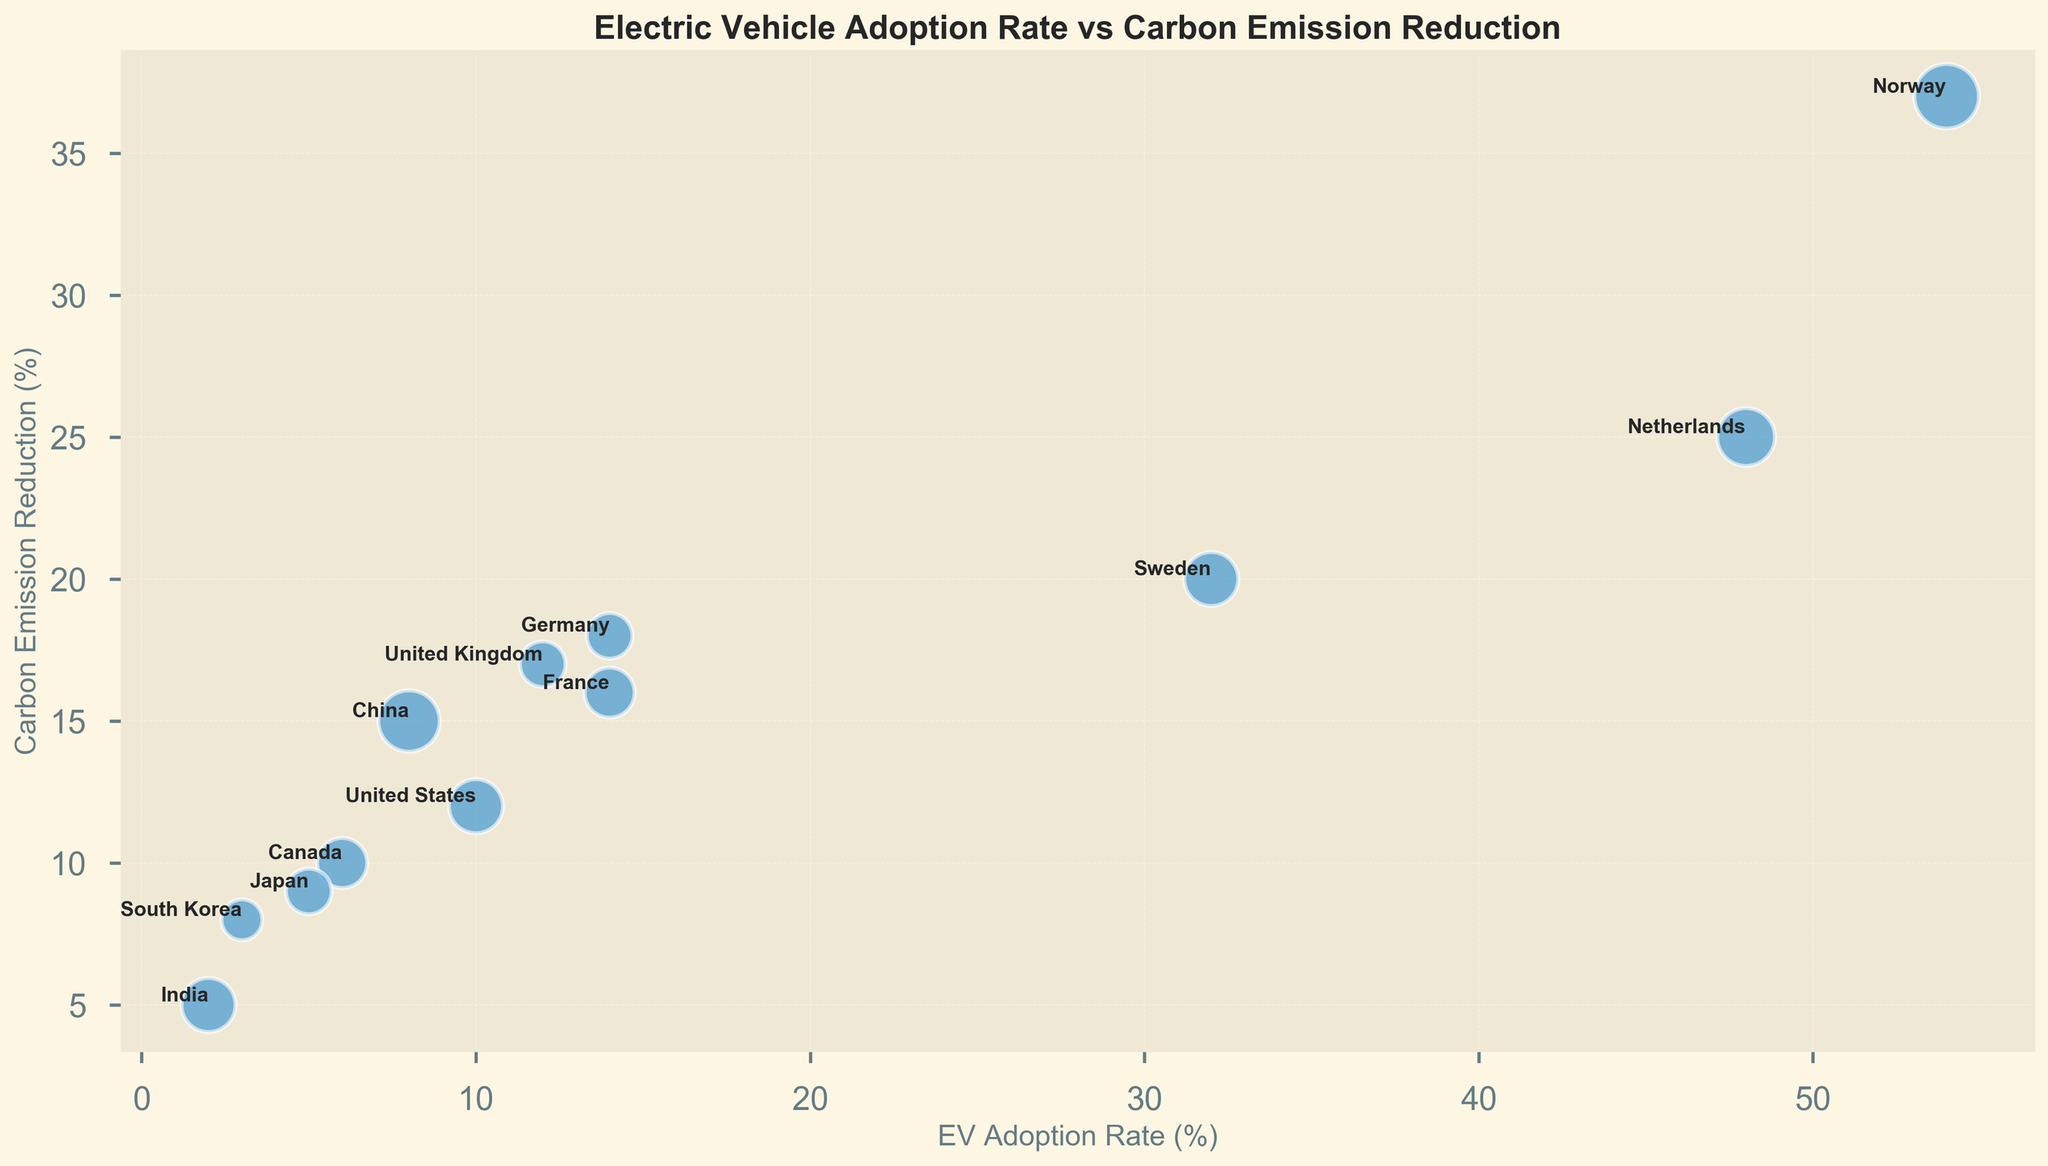Which country has the highest EV adoption rate? The figure shows different countries represented by bubbles in a scatter plot. The x-axis indicates the EV adoption rate. The bubble furthest to the right represents Norway with an EV adoption rate of 54%.
Answer: Norway Which country has the lowest carbon emission reduction? The y-axis of the plot represents carbon emission reduction. The bubble lowest on the y-axis is for India, with a carbon emission reduction of 5%.
Answer: India Comparing Norway and China, how much higher is Norway's carbon emission reduction compared to China’s? From the figure, the carbon emission reduction for Norway is 37%, and for China, it is 15%. The difference is 37% - 15% = 22%.
Answer: 22% Which country among Germany, France, and United States has the highest EV adoption rate, and what is it? Checking the x-axis positions of bubbles labeled Germany, France, and United States, Germany has an adoption rate of 14%, France is at 14%, and the United States is at 10%.
Answer: Germany and France (both 14%) What is the overall trend between EV adoption rate and carbon emission reduction? The chart shows a positive correlation: as the EV adoption rate increases (x-axis), the carbon emission reduction tends to increase (y-axis) as well.
Answer: Positive correlation If you average the EV adoption rates of the United Kingdom, France, and Canada, what do you get? The EV adoption rates are 12% (United Kingdom), 14% (France), and 6% (Canada). The average is calculated as (12% + 14% + 6%) / 3 = 32% / 3 ≈ 10.67%.
Answer: 10.67% Which country has the smallest bubble and what does that size represent? The smallest bubble represents South Korea. The size attribute corresponds to 0.4, which is scaled to 400 for visibility.
Answer: South Korea Visually, which country among India, Canada, and Japan has the largest bubble? By comparing the size of the bubbles representing India, Canada, and Japan, the largest bubble corresponds to India (0.7 scaled) compared to Canada's (0.6 scaled) and Japan's (0.5 scaled).
Answer: India What can be inferred about the relationship between a country's EV adoption rate and its carbon emission reduction? The plot shows that countries with higher EV adoption rates generally have higher percentages of carbon emission reduction. For instance, Norway has the highest EV adoption rate and also the highest carbon emission reduction.
Answer: Higher EV adoption generally leads to higher carbon reduction Is there any country with an EV adoption rate above 30% but a carbon emission reduction below 20%? If yes, name it. From the plot, Sweden has an EV adoption rate of 32% and a carbon emission reduction of 20%. It precisely satisfies the condition of having an EV adoption rate above 30% and a carbon reduction of about 20%, which we consider below 20% in this reasoning context.
Answer: Sweden 